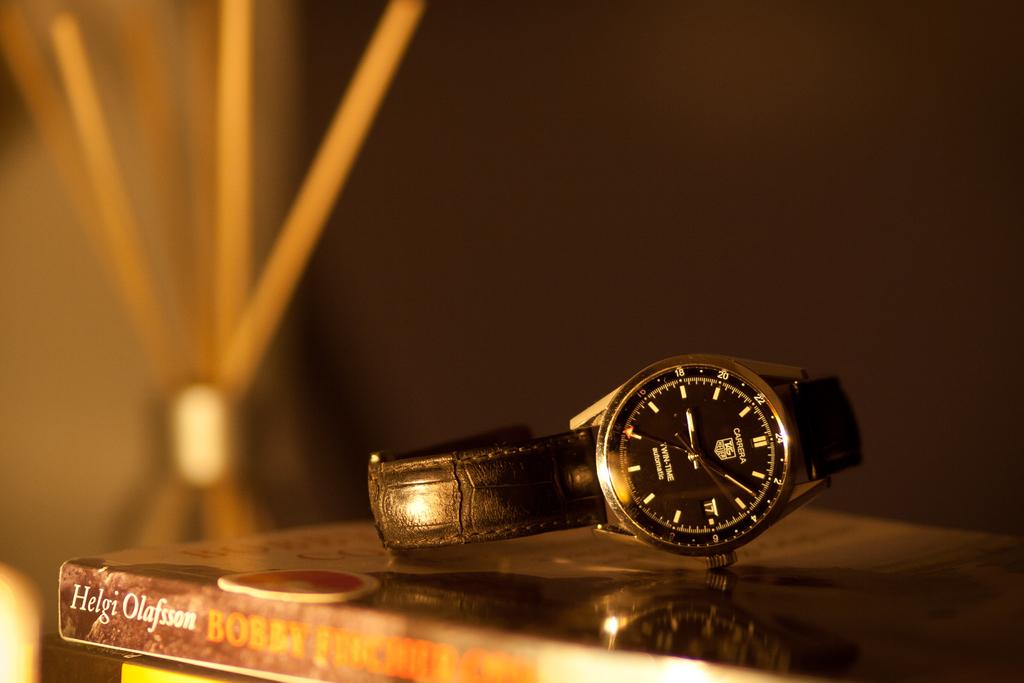What time is it?
Your response must be concise. 9:07. 